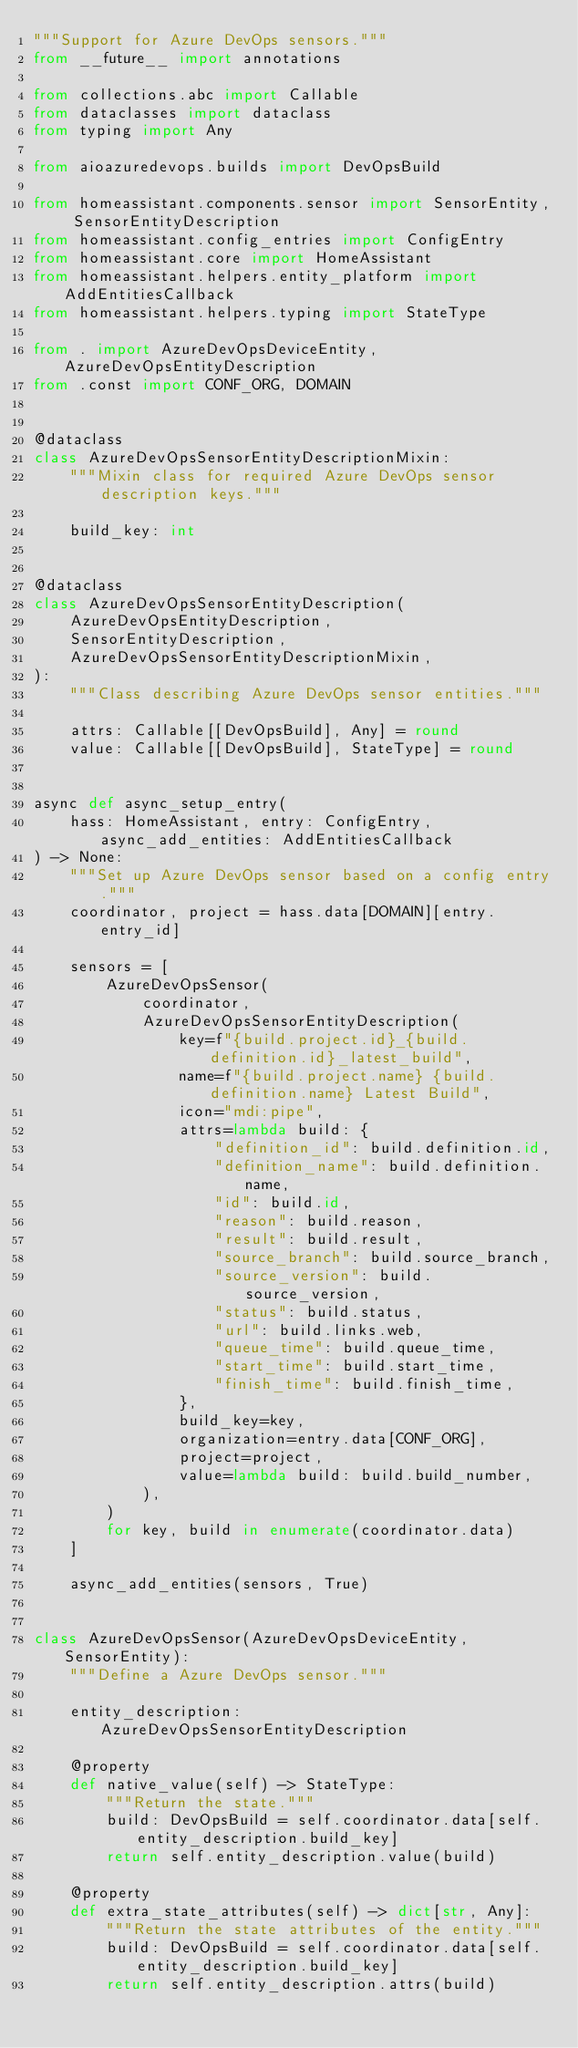<code> <loc_0><loc_0><loc_500><loc_500><_Python_>"""Support for Azure DevOps sensors."""
from __future__ import annotations

from collections.abc import Callable
from dataclasses import dataclass
from typing import Any

from aioazuredevops.builds import DevOpsBuild

from homeassistant.components.sensor import SensorEntity, SensorEntityDescription
from homeassistant.config_entries import ConfigEntry
from homeassistant.core import HomeAssistant
from homeassistant.helpers.entity_platform import AddEntitiesCallback
from homeassistant.helpers.typing import StateType

from . import AzureDevOpsDeviceEntity, AzureDevOpsEntityDescription
from .const import CONF_ORG, DOMAIN


@dataclass
class AzureDevOpsSensorEntityDescriptionMixin:
    """Mixin class for required Azure DevOps sensor description keys."""

    build_key: int


@dataclass
class AzureDevOpsSensorEntityDescription(
    AzureDevOpsEntityDescription,
    SensorEntityDescription,
    AzureDevOpsSensorEntityDescriptionMixin,
):
    """Class describing Azure DevOps sensor entities."""

    attrs: Callable[[DevOpsBuild], Any] = round
    value: Callable[[DevOpsBuild], StateType] = round


async def async_setup_entry(
    hass: HomeAssistant, entry: ConfigEntry, async_add_entities: AddEntitiesCallback
) -> None:
    """Set up Azure DevOps sensor based on a config entry."""
    coordinator, project = hass.data[DOMAIN][entry.entry_id]

    sensors = [
        AzureDevOpsSensor(
            coordinator,
            AzureDevOpsSensorEntityDescription(
                key=f"{build.project.id}_{build.definition.id}_latest_build",
                name=f"{build.project.name} {build.definition.name} Latest Build",
                icon="mdi:pipe",
                attrs=lambda build: {
                    "definition_id": build.definition.id,
                    "definition_name": build.definition.name,
                    "id": build.id,
                    "reason": build.reason,
                    "result": build.result,
                    "source_branch": build.source_branch,
                    "source_version": build.source_version,
                    "status": build.status,
                    "url": build.links.web,
                    "queue_time": build.queue_time,
                    "start_time": build.start_time,
                    "finish_time": build.finish_time,
                },
                build_key=key,
                organization=entry.data[CONF_ORG],
                project=project,
                value=lambda build: build.build_number,
            ),
        )
        for key, build in enumerate(coordinator.data)
    ]

    async_add_entities(sensors, True)


class AzureDevOpsSensor(AzureDevOpsDeviceEntity, SensorEntity):
    """Define a Azure DevOps sensor."""

    entity_description: AzureDevOpsSensorEntityDescription

    @property
    def native_value(self) -> StateType:
        """Return the state."""
        build: DevOpsBuild = self.coordinator.data[self.entity_description.build_key]
        return self.entity_description.value(build)

    @property
    def extra_state_attributes(self) -> dict[str, Any]:
        """Return the state attributes of the entity."""
        build: DevOpsBuild = self.coordinator.data[self.entity_description.build_key]
        return self.entity_description.attrs(build)
</code> 